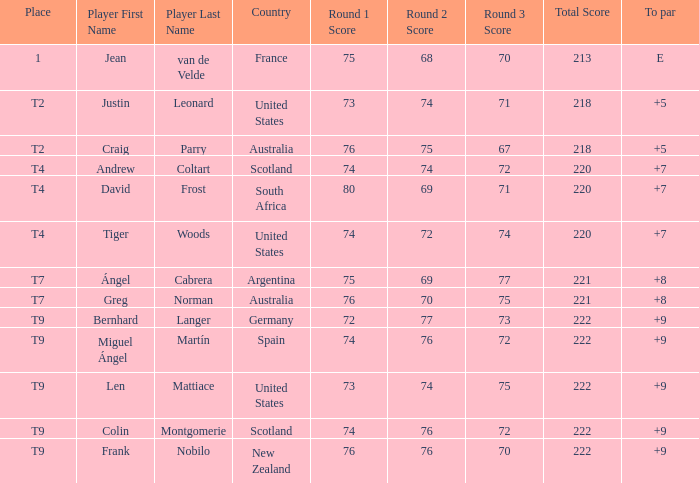What is the place number for the player with a To Par score of 'E'? 1.0. 